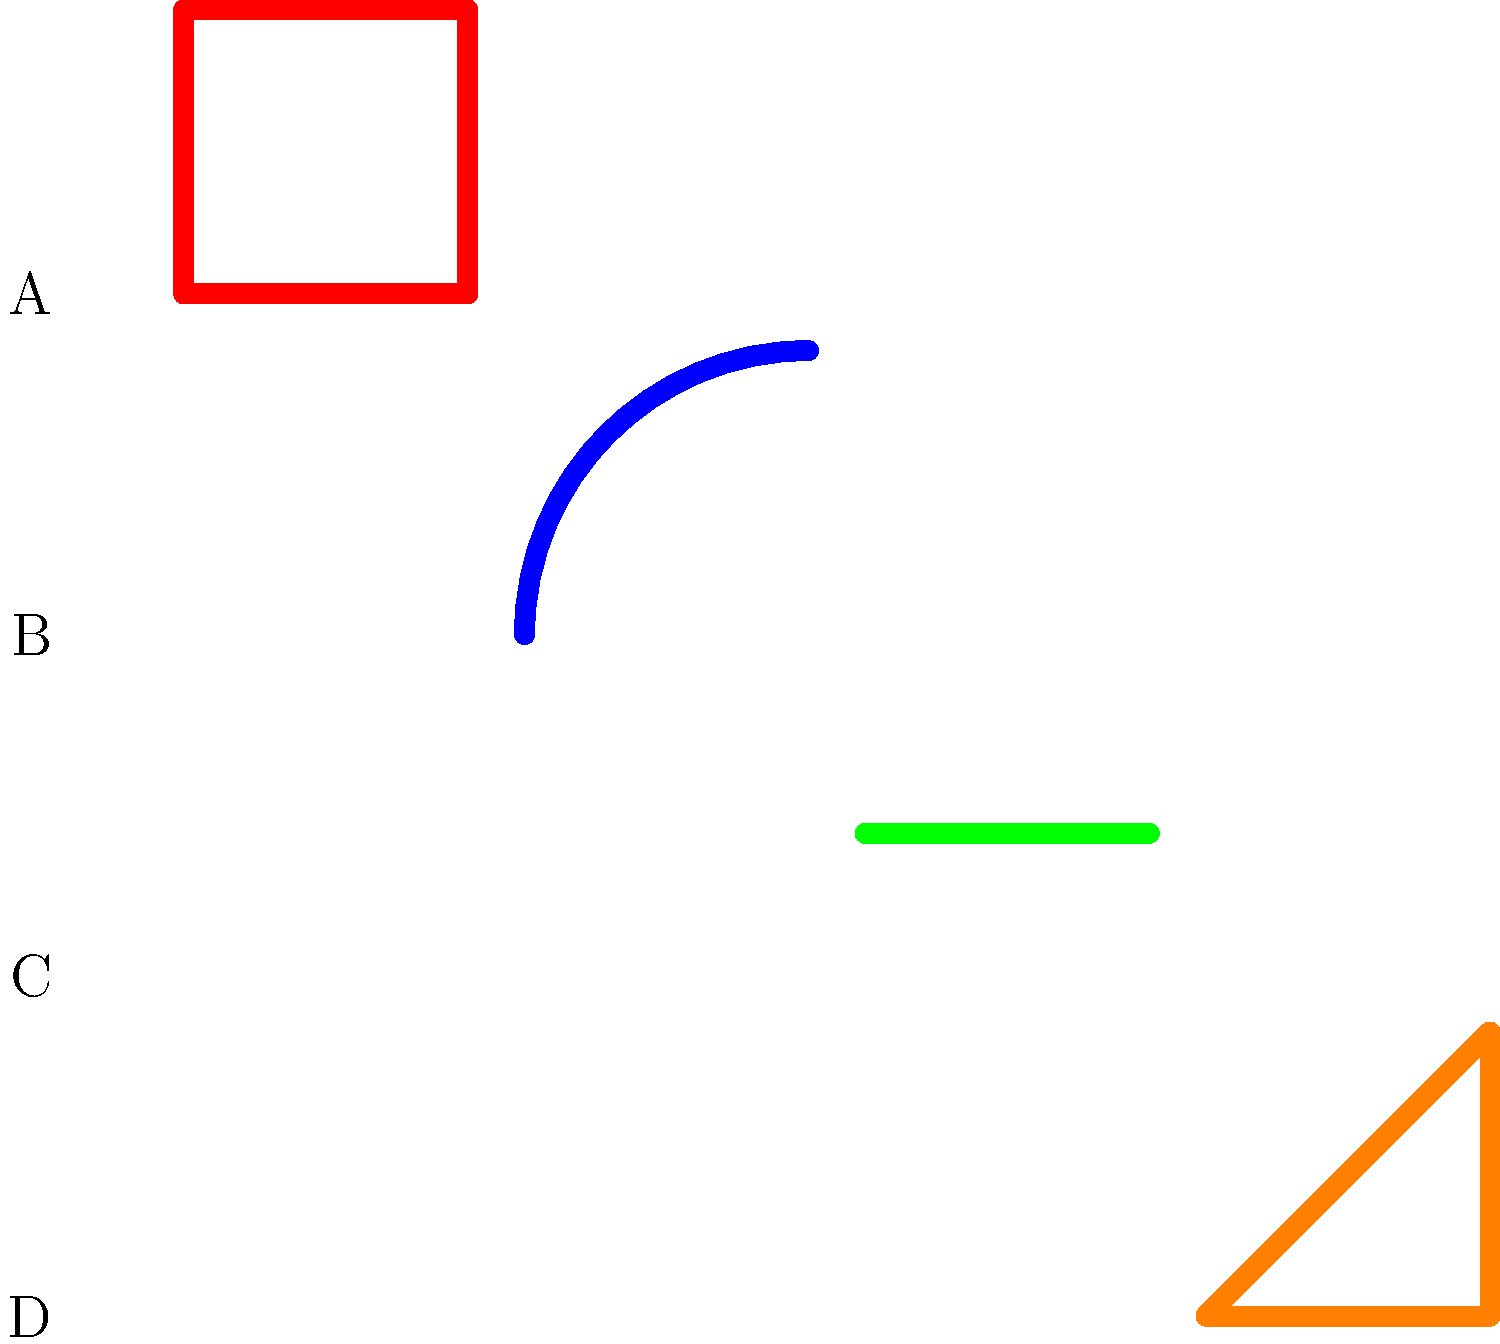Which of the graffiti styles shown above is commonly associated with the "throw-up" technique in Hip Hop culture? To identify the "throw-up" technique in graffiti, we need to understand its characteristics:

1. "Throw-ups" are quick to execute, often done in one or two colors.
2. They typically consist of bubble letters or simple outlines.
3. The style prioritizes speed and visibility over intricate details.

Analyzing the given styles:

A: This is a simple square, not representative of any specific graffiti technique.
B: This curved line resembles a "tag" or part of a more complex piece, but not a throw-up.
C: This straight line is too simple to be considered a throw-up.
D: This style shows a simple, outlined letter form that could be quickly executed. It has the characteristics of a throw-up: quick to do, simple outline, and easily readable.

Therefore, the style that best represents the "throw-up" technique is D.
Answer: D 